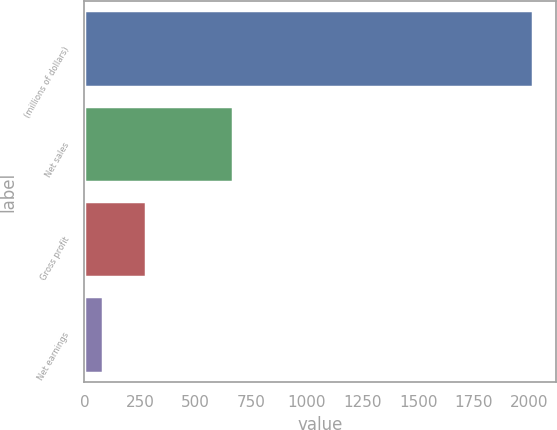Convert chart. <chart><loc_0><loc_0><loc_500><loc_500><bar_chart><fcel>(millions of dollars)<fcel>Net sales<fcel>Gross profit<fcel>Net earnings<nl><fcel>2017<fcel>669.6<fcel>278.38<fcel>85.2<nl></chart> 